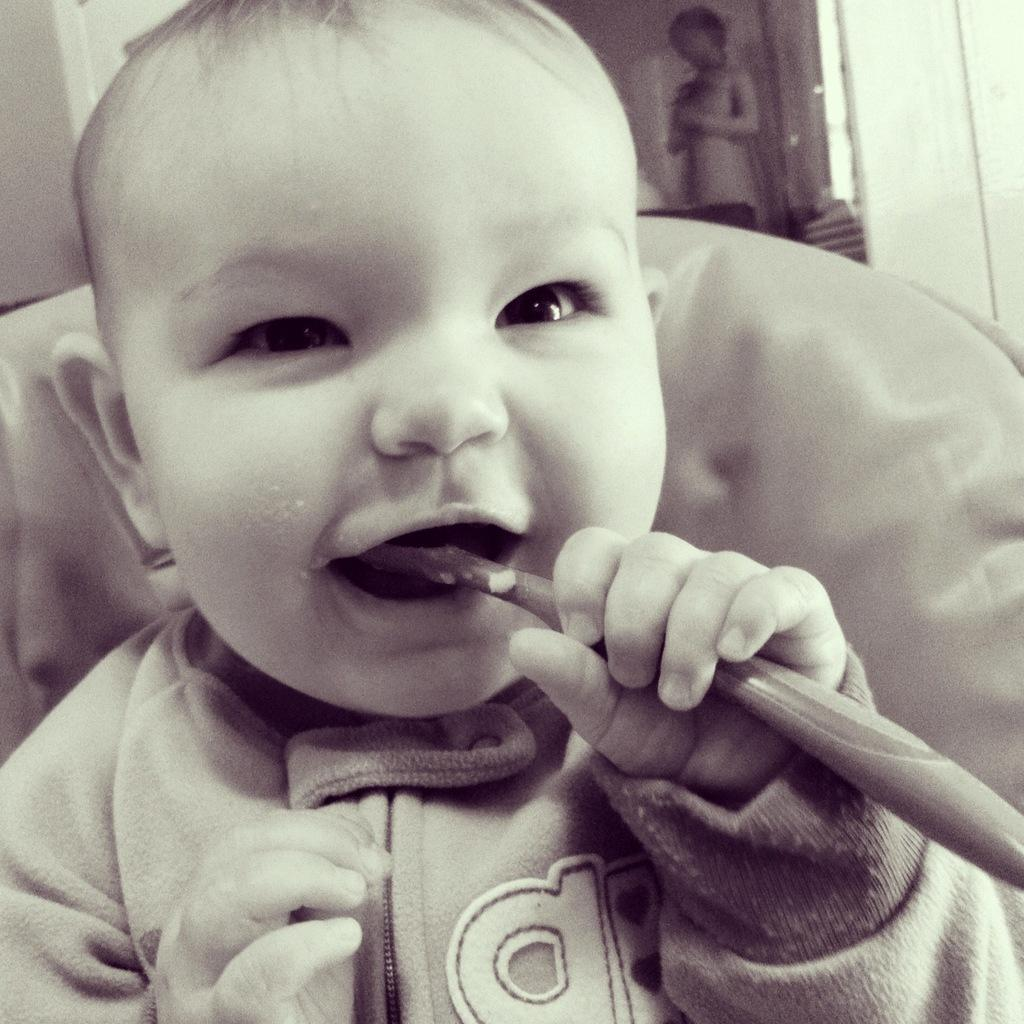What is the baby doing in the image? The baby is sitting on a chair and holding a brush in his hand. What is the baby doing with the brush? The baby has placed the brush in his mouth. Who is present in the image besides the baby? There is a person standing behind the baby in the image. What can be seen in the background of the image? There is a wall visible in the image. What type of paste is the baby using to stick objects on the wall in the image? There is no paste or objects being stuck on the wall in the image; the baby is holding a brush in his mouth. 